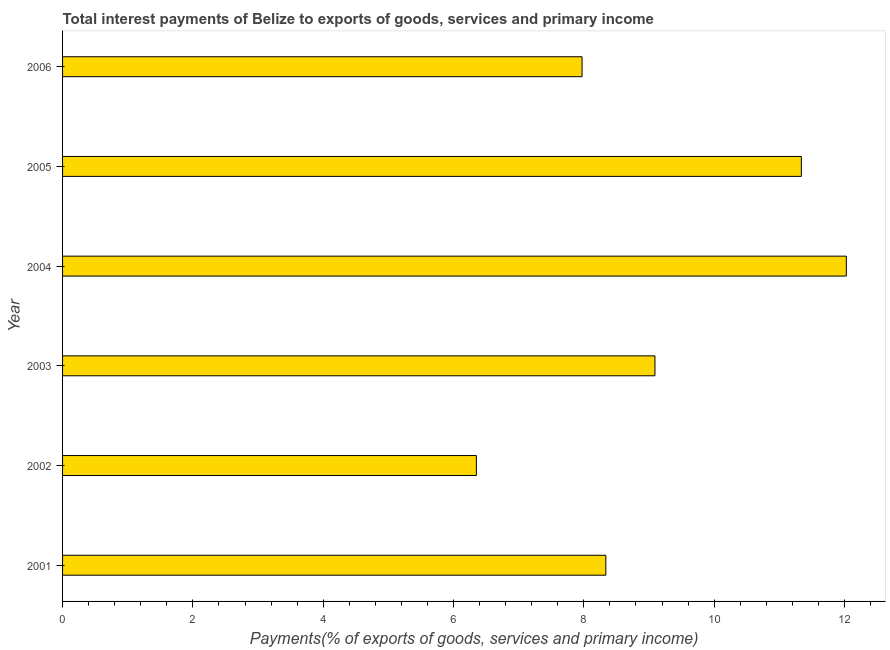Does the graph contain any zero values?
Your answer should be compact. No. What is the title of the graph?
Offer a terse response. Total interest payments of Belize to exports of goods, services and primary income. What is the label or title of the X-axis?
Ensure brevity in your answer.  Payments(% of exports of goods, services and primary income). What is the label or title of the Y-axis?
Ensure brevity in your answer.  Year. What is the total interest payments on external debt in 2006?
Provide a succinct answer. 7.97. Across all years, what is the maximum total interest payments on external debt?
Make the answer very short. 12.03. Across all years, what is the minimum total interest payments on external debt?
Your answer should be very brief. 6.35. What is the sum of the total interest payments on external debt?
Your answer should be very brief. 55.12. What is the difference between the total interest payments on external debt in 2003 and 2004?
Give a very brief answer. -2.94. What is the average total interest payments on external debt per year?
Offer a terse response. 9.19. What is the median total interest payments on external debt?
Make the answer very short. 8.71. In how many years, is the total interest payments on external debt greater than 0.4 %?
Make the answer very short. 6. What is the ratio of the total interest payments on external debt in 2001 to that in 2003?
Your answer should be very brief. 0.92. Is the difference between the total interest payments on external debt in 2004 and 2006 greater than the difference between any two years?
Offer a terse response. No. What is the difference between the highest and the second highest total interest payments on external debt?
Offer a very short reply. 0.69. What is the difference between the highest and the lowest total interest payments on external debt?
Ensure brevity in your answer.  5.68. How many years are there in the graph?
Offer a very short reply. 6. Are the values on the major ticks of X-axis written in scientific E-notation?
Your answer should be very brief. No. What is the Payments(% of exports of goods, services and primary income) in 2001?
Your answer should be compact. 8.34. What is the Payments(% of exports of goods, services and primary income) in 2002?
Make the answer very short. 6.35. What is the Payments(% of exports of goods, services and primary income) in 2003?
Keep it short and to the point. 9.09. What is the Payments(% of exports of goods, services and primary income) in 2004?
Make the answer very short. 12.03. What is the Payments(% of exports of goods, services and primary income) of 2005?
Keep it short and to the point. 11.34. What is the Payments(% of exports of goods, services and primary income) of 2006?
Ensure brevity in your answer.  7.97. What is the difference between the Payments(% of exports of goods, services and primary income) in 2001 and 2002?
Offer a terse response. 1.99. What is the difference between the Payments(% of exports of goods, services and primary income) in 2001 and 2003?
Offer a very short reply. -0.75. What is the difference between the Payments(% of exports of goods, services and primary income) in 2001 and 2004?
Give a very brief answer. -3.69. What is the difference between the Payments(% of exports of goods, services and primary income) in 2001 and 2005?
Your answer should be compact. -3. What is the difference between the Payments(% of exports of goods, services and primary income) in 2001 and 2006?
Keep it short and to the point. 0.36. What is the difference between the Payments(% of exports of goods, services and primary income) in 2002 and 2003?
Your response must be concise. -2.74. What is the difference between the Payments(% of exports of goods, services and primary income) in 2002 and 2004?
Provide a succinct answer. -5.68. What is the difference between the Payments(% of exports of goods, services and primary income) in 2002 and 2005?
Your answer should be very brief. -4.99. What is the difference between the Payments(% of exports of goods, services and primary income) in 2002 and 2006?
Ensure brevity in your answer.  -1.62. What is the difference between the Payments(% of exports of goods, services and primary income) in 2003 and 2004?
Your answer should be compact. -2.94. What is the difference between the Payments(% of exports of goods, services and primary income) in 2003 and 2005?
Make the answer very short. -2.25. What is the difference between the Payments(% of exports of goods, services and primary income) in 2003 and 2006?
Provide a short and direct response. 1.12. What is the difference between the Payments(% of exports of goods, services and primary income) in 2004 and 2005?
Offer a very short reply. 0.69. What is the difference between the Payments(% of exports of goods, services and primary income) in 2004 and 2006?
Provide a short and direct response. 4.06. What is the difference between the Payments(% of exports of goods, services and primary income) in 2005 and 2006?
Your response must be concise. 3.37. What is the ratio of the Payments(% of exports of goods, services and primary income) in 2001 to that in 2002?
Make the answer very short. 1.31. What is the ratio of the Payments(% of exports of goods, services and primary income) in 2001 to that in 2003?
Provide a short and direct response. 0.92. What is the ratio of the Payments(% of exports of goods, services and primary income) in 2001 to that in 2004?
Give a very brief answer. 0.69. What is the ratio of the Payments(% of exports of goods, services and primary income) in 2001 to that in 2005?
Ensure brevity in your answer.  0.73. What is the ratio of the Payments(% of exports of goods, services and primary income) in 2001 to that in 2006?
Offer a very short reply. 1.05. What is the ratio of the Payments(% of exports of goods, services and primary income) in 2002 to that in 2003?
Ensure brevity in your answer.  0.7. What is the ratio of the Payments(% of exports of goods, services and primary income) in 2002 to that in 2004?
Keep it short and to the point. 0.53. What is the ratio of the Payments(% of exports of goods, services and primary income) in 2002 to that in 2005?
Offer a terse response. 0.56. What is the ratio of the Payments(% of exports of goods, services and primary income) in 2002 to that in 2006?
Make the answer very short. 0.8. What is the ratio of the Payments(% of exports of goods, services and primary income) in 2003 to that in 2004?
Ensure brevity in your answer.  0.76. What is the ratio of the Payments(% of exports of goods, services and primary income) in 2003 to that in 2005?
Your answer should be very brief. 0.8. What is the ratio of the Payments(% of exports of goods, services and primary income) in 2003 to that in 2006?
Give a very brief answer. 1.14. What is the ratio of the Payments(% of exports of goods, services and primary income) in 2004 to that in 2005?
Offer a terse response. 1.06. What is the ratio of the Payments(% of exports of goods, services and primary income) in 2004 to that in 2006?
Provide a short and direct response. 1.51. What is the ratio of the Payments(% of exports of goods, services and primary income) in 2005 to that in 2006?
Provide a short and direct response. 1.42. 